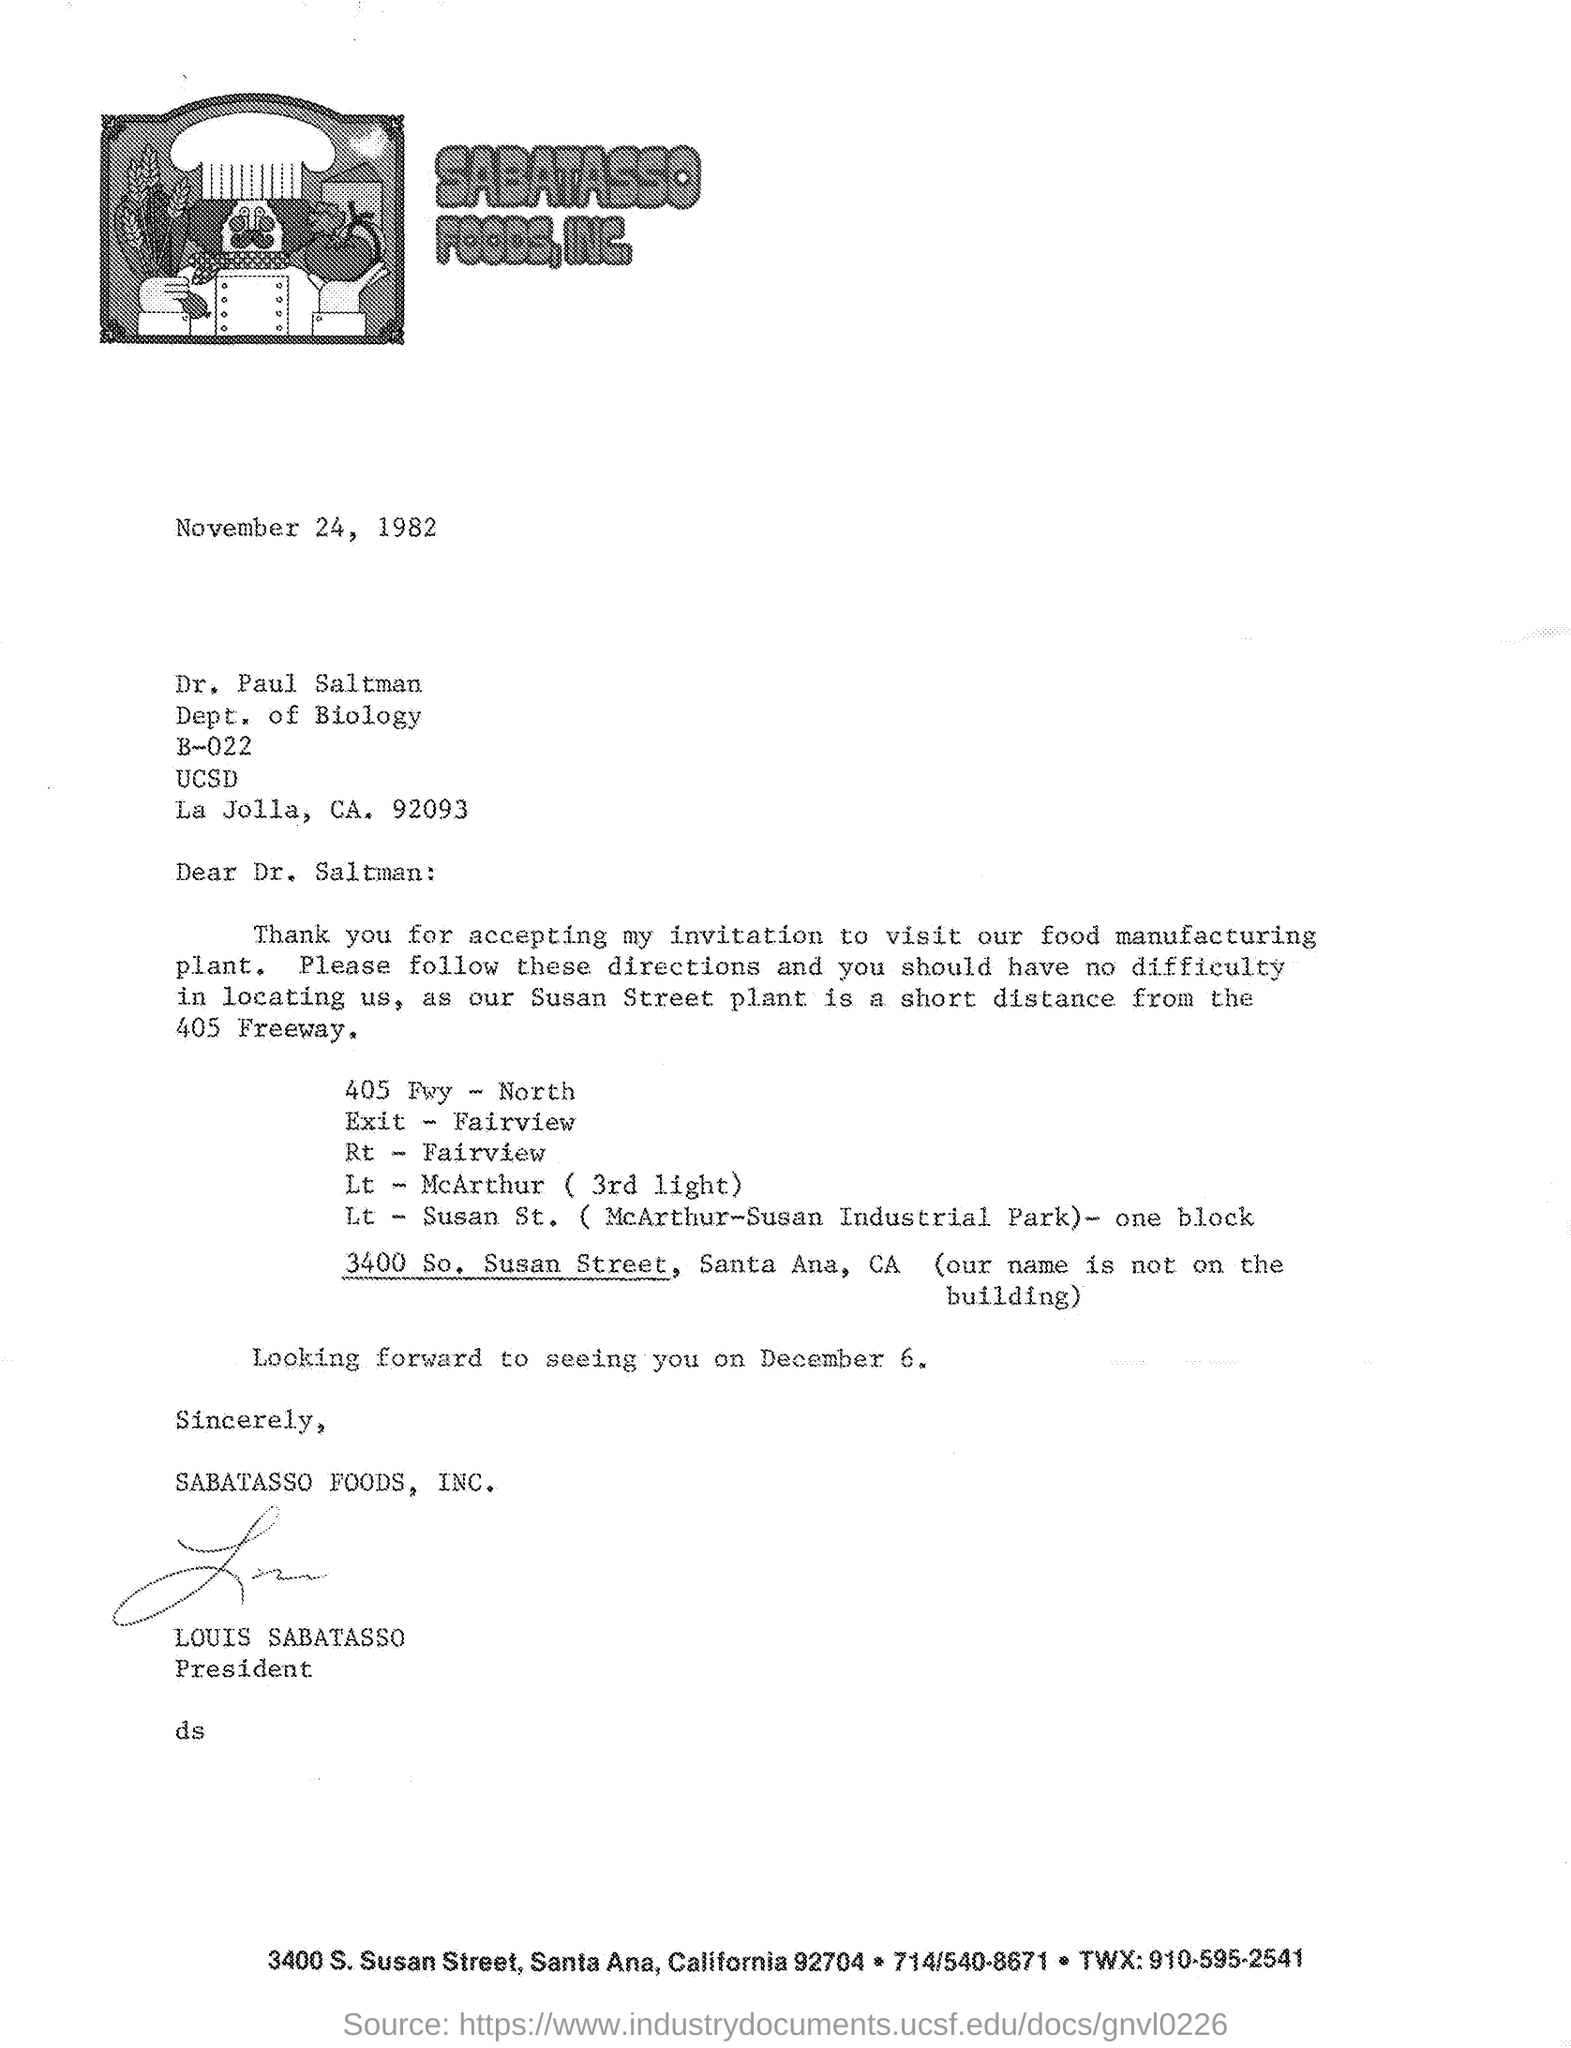What is the date mentioned in the given letter ?
Give a very brief answer. November 24, 1982. To which department dr. paul saltman belongs to ?
Give a very brief answer. Dept. of biology. Who signed at the bottom of the letter as shown in the given letter ?
Offer a terse response. Louis Sabatasso. What is the designation of louis sabatasso as mentioned in the given letter ?
Make the answer very short. President. 